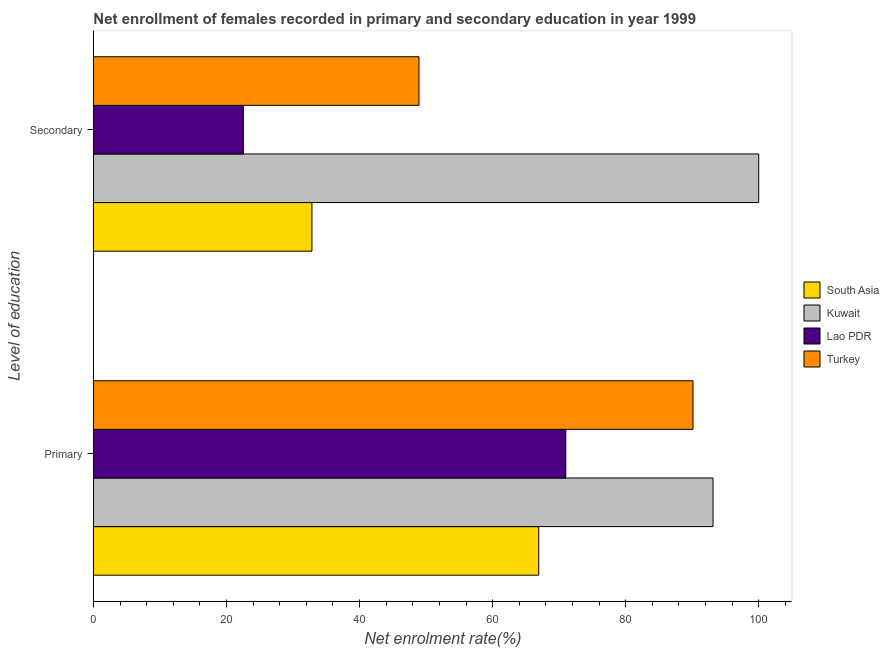Are the number of bars on each tick of the Y-axis equal?
Give a very brief answer. Yes. How many bars are there on the 1st tick from the bottom?
Make the answer very short. 4. What is the label of the 2nd group of bars from the top?
Give a very brief answer. Primary. What is the enrollment rate in secondary education in Kuwait?
Your answer should be compact. 100. Across all countries, what is the maximum enrollment rate in secondary education?
Provide a succinct answer. 100. Across all countries, what is the minimum enrollment rate in secondary education?
Keep it short and to the point. 22.53. In which country was the enrollment rate in primary education maximum?
Your response must be concise. Kuwait. In which country was the enrollment rate in primary education minimum?
Offer a terse response. South Asia. What is the total enrollment rate in secondary education in the graph?
Ensure brevity in your answer.  204.31. What is the difference between the enrollment rate in primary education in South Asia and that in Turkey?
Ensure brevity in your answer.  -23.19. What is the difference between the enrollment rate in secondary education in Turkey and the enrollment rate in primary education in South Asia?
Offer a terse response. -17.99. What is the average enrollment rate in primary education per country?
Provide a short and direct response. 80.3. What is the difference between the enrollment rate in secondary education and enrollment rate in primary education in South Asia?
Your response must be concise. -34.08. In how many countries, is the enrollment rate in primary education greater than 48 %?
Offer a terse response. 4. What is the ratio of the enrollment rate in secondary education in Turkey to that in Lao PDR?
Provide a short and direct response. 2.17. Is the enrollment rate in primary education in Lao PDR less than that in South Asia?
Keep it short and to the point. No. In how many countries, is the enrollment rate in secondary education greater than the average enrollment rate in secondary education taken over all countries?
Your answer should be very brief. 1. What does the 3rd bar from the top in Secondary represents?
Provide a succinct answer. Kuwait. What does the 3rd bar from the bottom in Primary represents?
Give a very brief answer. Lao PDR. How many bars are there?
Give a very brief answer. 8. Are the values on the major ticks of X-axis written in scientific E-notation?
Your answer should be very brief. No. Does the graph contain any zero values?
Your response must be concise. No. Where does the legend appear in the graph?
Your response must be concise. Center right. How many legend labels are there?
Keep it short and to the point. 4. How are the legend labels stacked?
Offer a terse response. Vertical. What is the title of the graph?
Offer a very short reply. Net enrollment of females recorded in primary and secondary education in year 1999. Does "France" appear as one of the legend labels in the graph?
Your response must be concise. No. What is the label or title of the X-axis?
Ensure brevity in your answer.  Net enrolment rate(%). What is the label or title of the Y-axis?
Your answer should be very brief. Level of education. What is the Net enrolment rate(%) in South Asia in Primary?
Ensure brevity in your answer.  66.93. What is the Net enrolment rate(%) in Kuwait in Primary?
Make the answer very short. 93.13. What is the Net enrolment rate(%) of Lao PDR in Primary?
Keep it short and to the point. 71. What is the Net enrolment rate(%) in Turkey in Primary?
Provide a succinct answer. 90.12. What is the Net enrolment rate(%) of South Asia in Secondary?
Your answer should be very brief. 32.84. What is the Net enrolment rate(%) of Kuwait in Secondary?
Keep it short and to the point. 100. What is the Net enrolment rate(%) of Lao PDR in Secondary?
Provide a short and direct response. 22.53. What is the Net enrolment rate(%) of Turkey in Secondary?
Make the answer very short. 48.94. Across all Level of education, what is the maximum Net enrolment rate(%) of South Asia?
Offer a very short reply. 66.93. Across all Level of education, what is the maximum Net enrolment rate(%) of Lao PDR?
Keep it short and to the point. 71. Across all Level of education, what is the maximum Net enrolment rate(%) of Turkey?
Your answer should be very brief. 90.12. Across all Level of education, what is the minimum Net enrolment rate(%) of South Asia?
Offer a terse response. 32.84. Across all Level of education, what is the minimum Net enrolment rate(%) in Kuwait?
Give a very brief answer. 93.13. Across all Level of education, what is the minimum Net enrolment rate(%) in Lao PDR?
Provide a short and direct response. 22.53. Across all Level of education, what is the minimum Net enrolment rate(%) of Turkey?
Ensure brevity in your answer.  48.94. What is the total Net enrolment rate(%) in South Asia in the graph?
Offer a terse response. 99.77. What is the total Net enrolment rate(%) of Kuwait in the graph?
Your answer should be compact. 193.13. What is the total Net enrolment rate(%) in Lao PDR in the graph?
Offer a terse response. 93.53. What is the total Net enrolment rate(%) of Turkey in the graph?
Provide a short and direct response. 139.06. What is the difference between the Net enrolment rate(%) of South Asia in Primary and that in Secondary?
Give a very brief answer. 34.09. What is the difference between the Net enrolment rate(%) of Kuwait in Primary and that in Secondary?
Ensure brevity in your answer.  -6.87. What is the difference between the Net enrolment rate(%) of Lao PDR in Primary and that in Secondary?
Make the answer very short. 48.47. What is the difference between the Net enrolment rate(%) of Turkey in Primary and that in Secondary?
Keep it short and to the point. 41.18. What is the difference between the Net enrolment rate(%) in South Asia in Primary and the Net enrolment rate(%) in Kuwait in Secondary?
Provide a short and direct response. -33.07. What is the difference between the Net enrolment rate(%) of South Asia in Primary and the Net enrolment rate(%) of Lao PDR in Secondary?
Offer a very short reply. 44.4. What is the difference between the Net enrolment rate(%) of South Asia in Primary and the Net enrolment rate(%) of Turkey in Secondary?
Ensure brevity in your answer.  17.99. What is the difference between the Net enrolment rate(%) of Kuwait in Primary and the Net enrolment rate(%) of Lao PDR in Secondary?
Your answer should be very brief. 70.6. What is the difference between the Net enrolment rate(%) of Kuwait in Primary and the Net enrolment rate(%) of Turkey in Secondary?
Give a very brief answer. 44.2. What is the difference between the Net enrolment rate(%) in Lao PDR in Primary and the Net enrolment rate(%) in Turkey in Secondary?
Make the answer very short. 22.06. What is the average Net enrolment rate(%) of South Asia per Level of education?
Your answer should be compact. 49.89. What is the average Net enrolment rate(%) in Kuwait per Level of education?
Your answer should be very brief. 96.57. What is the average Net enrolment rate(%) in Lao PDR per Level of education?
Provide a short and direct response. 46.77. What is the average Net enrolment rate(%) in Turkey per Level of education?
Ensure brevity in your answer.  69.53. What is the difference between the Net enrolment rate(%) in South Asia and Net enrolment rate(%) in Kuwait in Primary?
Your answer should be compact. -26.2. What is the difference between the Net enrolment rate(%) of South Asia and Net enrolment rate(%) of Lao PDR in Primary?
Offer a very short reply. -4.07. What is the difference between the Net enrolment rate(%) in South Asia and Net enrolment rate(%) in Turkey in Primary?
Offer a very short reply. -23.19. What is the difference between the Net enrolment rate(%) of Kuwait and Net enrolment rate(%) of Lao PDR in Primary?
Keep it short and to the point. 22.13. What is the difference between the Net enrolment rate(%) in Kuwait and Net enrolment rate(%) in Turkey in Primary?
Ensure brevity in your answer.  3.01. What is the difference between the Net enrolment rate(%) in Lao PDR and Net enrolment rate(%) in Turkey in Primary?
Provide a succinct answer. -19.12. What is the difference between the Net enrolment rate(%) in South Asia and Net enrolment rate(%) in Kuwait in Secondary?
Make the answer very short. -67.16. What is the difference between the Net enrolment rate(%) of South Asia and Net enrolment rate(%) of Lao PDR in Secondary?
Offer a terse response. 10.31. What is the difference between the Net enrolment rate(%) of South Asia and Net enrolment rate(%) of Turkey in Secondary?
Offer a very short reply. -16.09. What is the difference between the Net enrolment rate(%) in Kuwait and Net enrolment rate(%) in Lao PDR in Secondary?
Your answer should be very brief. 77.47. What is the difference between the Net enrolment rate(%) in Kuwait and Net enrolment rate(%) in Turkey in Secondary?
Your response must be concise. 51.06. What is the difference between the Net enrolment rate(%) of Lao PDR and Net enrolment rate(%) of Turkey in Secondary?
Your answer should be compact. -26.4. What is the ratio of the Net enrolment rate(%) in South Asia in Primary to that in Secondary?
Give a very brief answer. 2.04. What is the ratio of the Net enrolment rate(%) in Kuwait in Primary to that in Secondary?
Provide a succinct answer. 0.93. What is the ratio of the Net enrolment rate(%) of Lao PDR in Primary to that in Secondary?
Provide a succinct answer. 3.15. What is the ratio of the Net enrolment rate(%) in Turkey in Primary to that in Secondary?
Keep it short and to the point. 1.84. What is the difference between the highest and the second highest Net enrolment rate(%) of South Asia?
Offer a terse response. 34.09. What is the difference between the highest and the second highest Net enrolment rate(%) in Kuwait?
Your response must be concise. 6.87. What is the difference between the highest and the second highest Net enrolment rate(%) in Lao PDR?
Offer a very short reply. 48.47. What is the difference between the highest and the second highest Net enrolment rate(%) of Turkey?
Your response must be concise. 41.18. What is the difference between the highest and the lowest Net enrolment rate(%) of South Asia?
Give a very brief answer. 34.09. What is the difference between the highest and the lowest Net enrolment rate(%) of Kuwait?
Provide a short and direct response. 6.87. What is the difference between the highest and the lowest Net enrolment rate(%) of Lao PDR?
Give a very brief answer. 48.47. What is the difference between the highest and the lowest Net enrolment rate(%) in Turkey?
Keep it short and to the point. 41.18. 